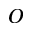Convert formula to latex. <formula><loc_0><loc_0><loc_500><loc_500>^ { O }</formula> 